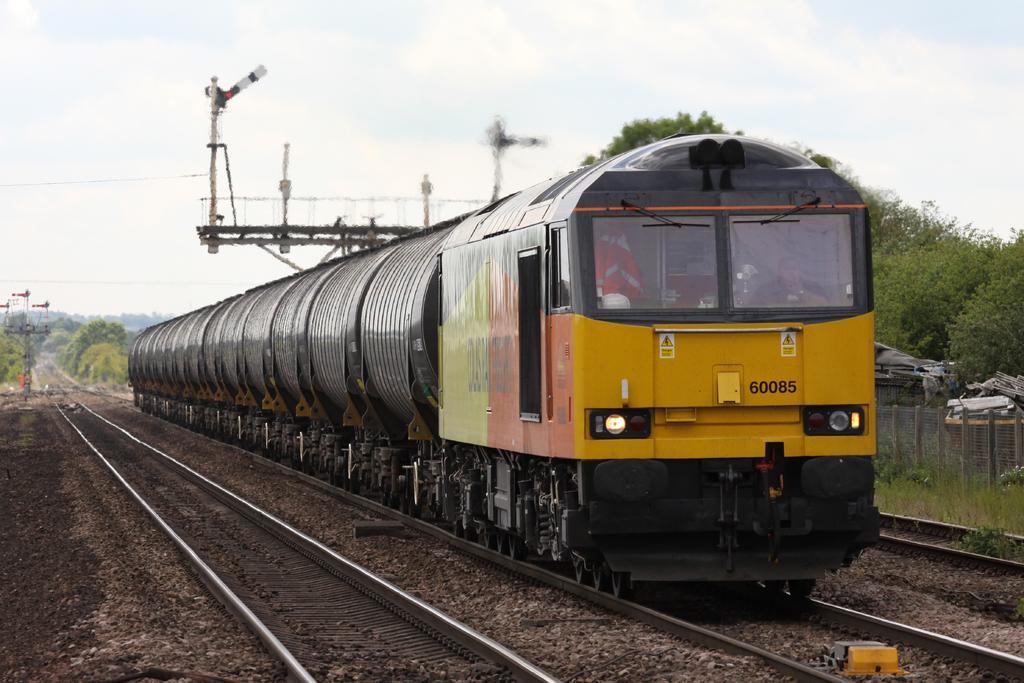In one or two sentences, can you explain what this image depicts? In this image there is a train moving on a track, in the background there are trees, sky and electrical poles. 